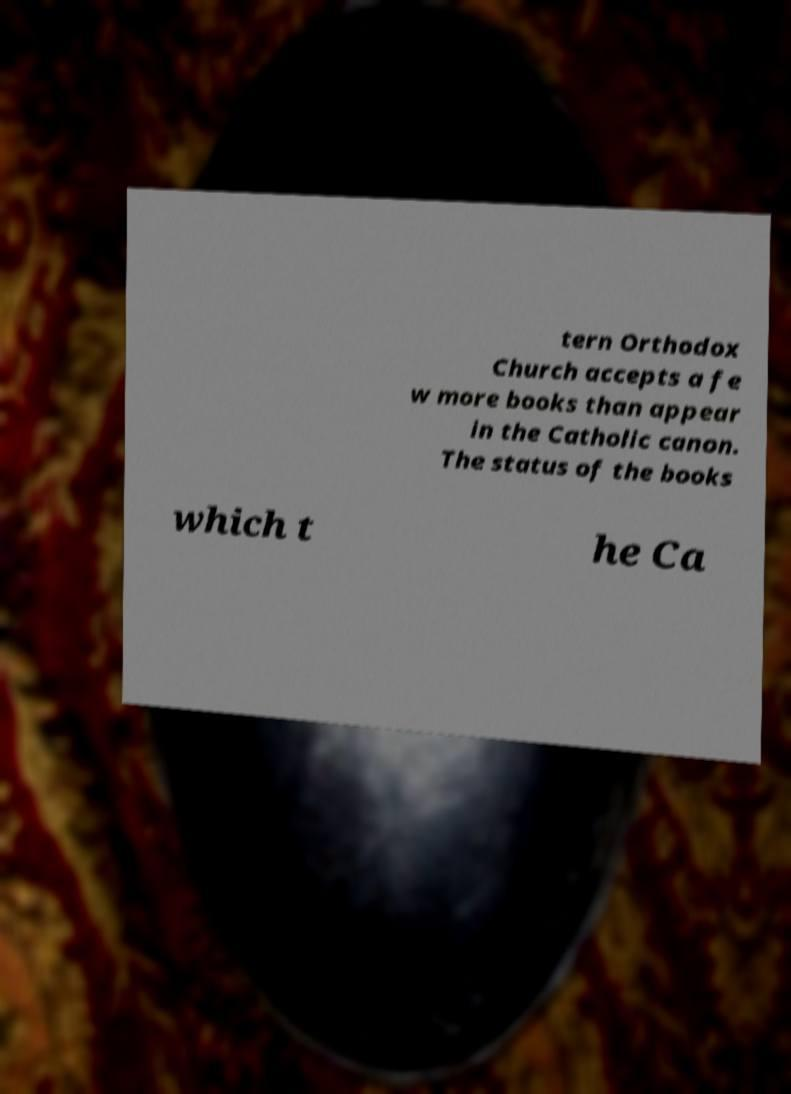Please identify and transcribe the text found in this image. tern Orthodox Church accepts a fe w more books than appear in the Catholic canon. The status of the books which t he Ca 